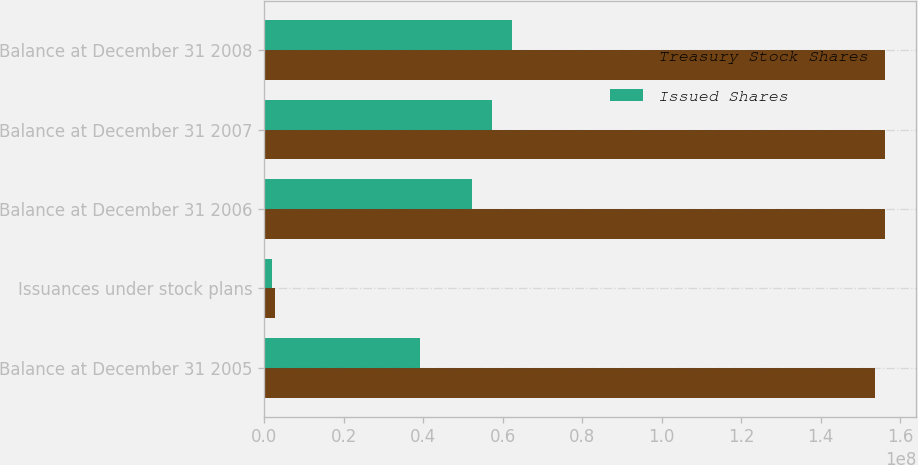Convert chart. <chart><loc_0><loc_0><loc_500><loc_500><stacked_bar_chart><ecel><fcel>Balance at December 31 2005<fcel>Issuances under stock plans<fcel>Balance at December 31 2006<fcel>Balance at December 31 2007<fcel>Balance at December 31 2008<nl><fcel>Treasury Stock Shares<fcel>1.53549e+08<fcel>2.68498e+06<fcel>1.56234e+08<fcel>1.56234e+08<fcel>1.56234e+08<nl><fcel>Issued Shares<fcel>3.92147e+07<fcel>1.95262e+06<fcel>5.21696e+07<fcel>5.72027e+07<fcel>6.23536e+07<nl></chart> 